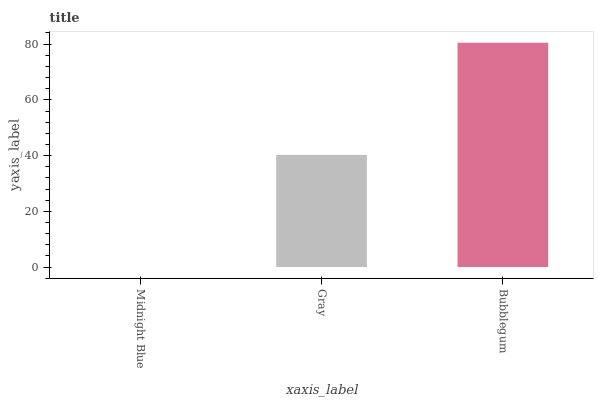Is Midnight Blue the minimum?
Answer yes or no. Yes. Is Bubblegum the maximum?
Answer yes or no. Yes. Is Gray the minimum?
Answer yes or no. No. Is Gray the maximum?
Answer yes or no. No. Is Gray greater than Midnight Blue?
Answer yes or no. Yes. Is Midnight Blue less than Gray?
Answer yes or no. Yes. Is Midnight Blue greater than Gray?
Answer yes or no. No. Is Gray less than Midnight Blue?
Answer yes or no. No. Is Gray the high median?
Answer yes or no. Yes. Is Gray the low median?
Answer yes or no. Yes. Is Midnight Blue the high median?
Answer yes or no. No. Is Midnight Blue the low median?
Answer yes or no. No. 